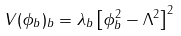Convert formula to latex. <formula><loc_0><loc_0><loc_500><loc_500>V ( \phi _ { b } ) _ { b } = \lambda _ { b } \left [ \phi _ { b } ^ { 2 } - \Lambda ^ { 2 } \right ] ^ { 2 }</formula> 